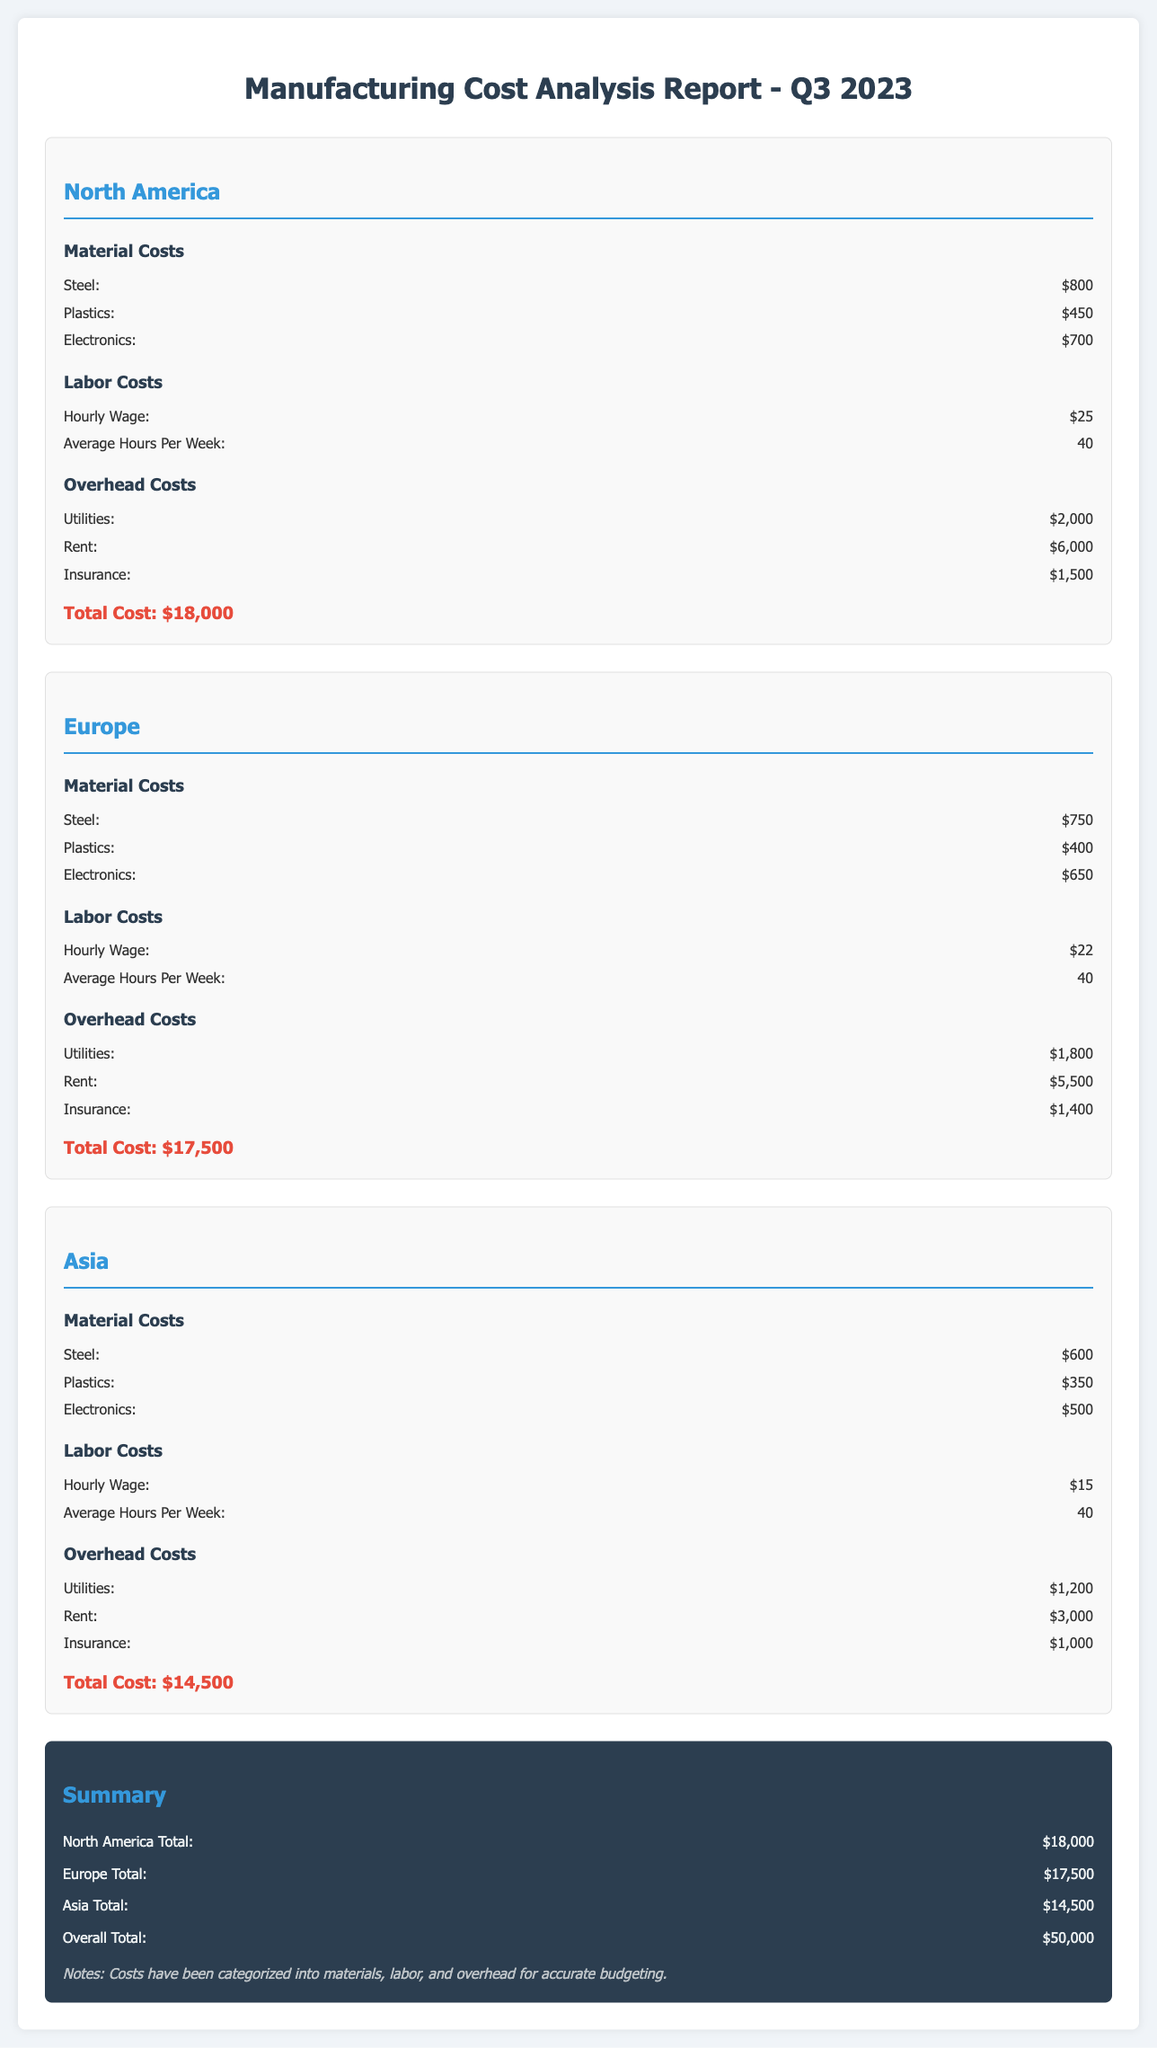What is the total cost for North America? The total cost for North America is listed in the document, which is $18,000.
Answer: $18,000 What is the hourly wage for labor in Asia? The hourly wage for labor in Asia is specified in the document as $15.
Answer: $15 How much is spent on utilities in Europe? The document states that utilities costs in Europe amount to $1,800.
Answer: $1,800 Which region has the highest total cost? By comparing the total costs from each region, North America with $18,000 has the highest total.
Answer: North America What is the total overhead cost for North America? Total overhead costs consist of utilities, rent, and insurance which collectively equals $9,500.
Answer: $9,500 How much do materials cost in Asia? The combined cost of materials in Asia is specified in the document, adding up to $1,450.
Answer: $1,450 What is the total cost across all regions? The overall total cost is provided in the summary of the document as $50,000.
Answer: $50,000 What is the average hours worked per week for labor in Europe? The document indicates that average hours per week for labor in Europe is 40.
Answer: 40 What are the insurance costs in North America? The document specifies that insurance costs in North America are $1,500.
Answer: $1,500 